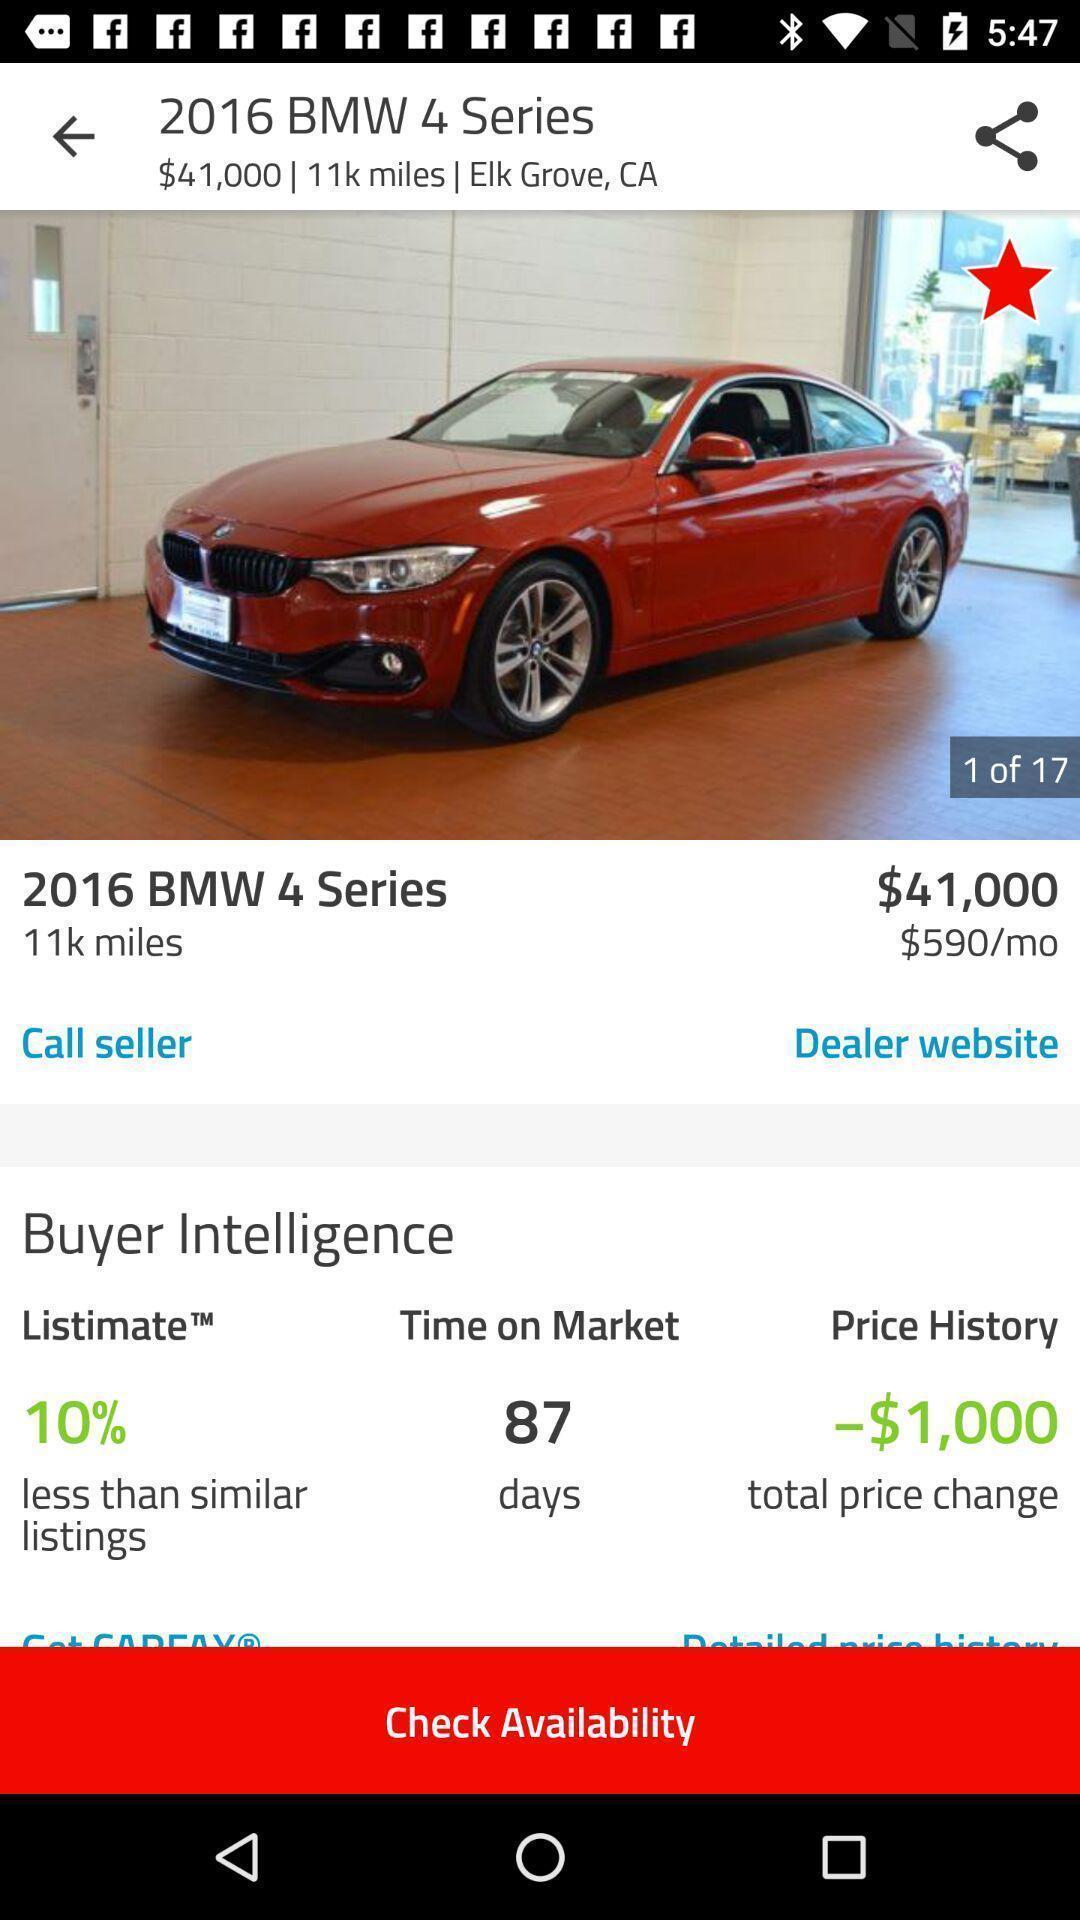Tell me about the visual elements in this screen capture. Page for checking availability of a car. 